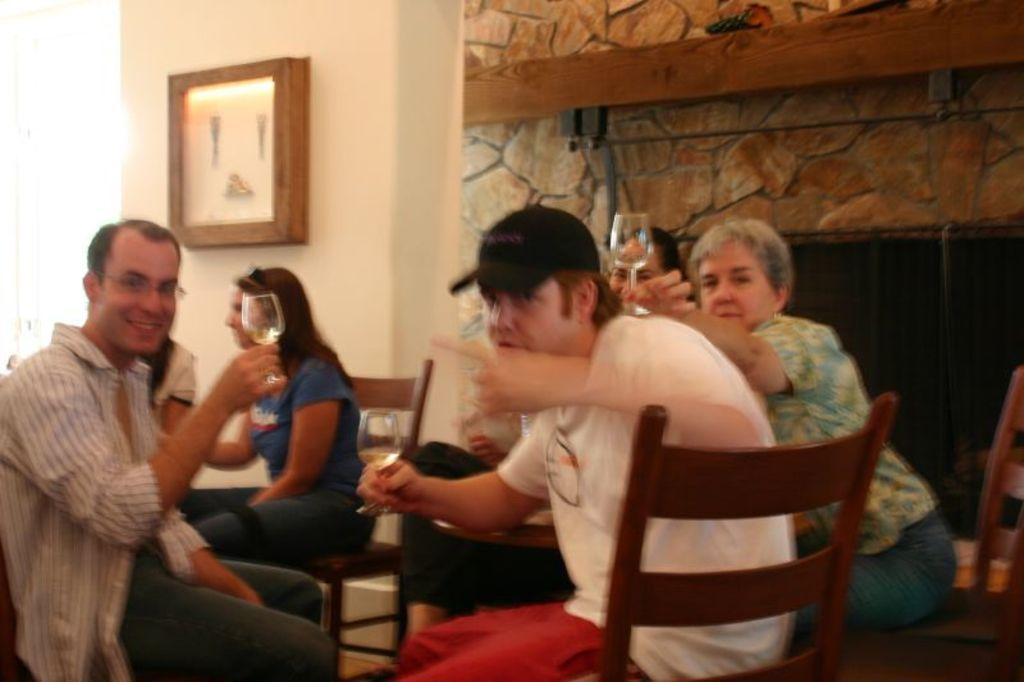What is the main subject of the image? The main subject of the image is a group of people. What are the people in the image doing? The people are sitting on chairs. What objects do the people have in their hands? Each person has glasses in their hands. What is in the glasses that the people are holding? Each person has wine in their glasses. Where is the nearest playground to the location of the people in the image? There is no information about a playground or the location of the people in the image, so it cannot be determined. 